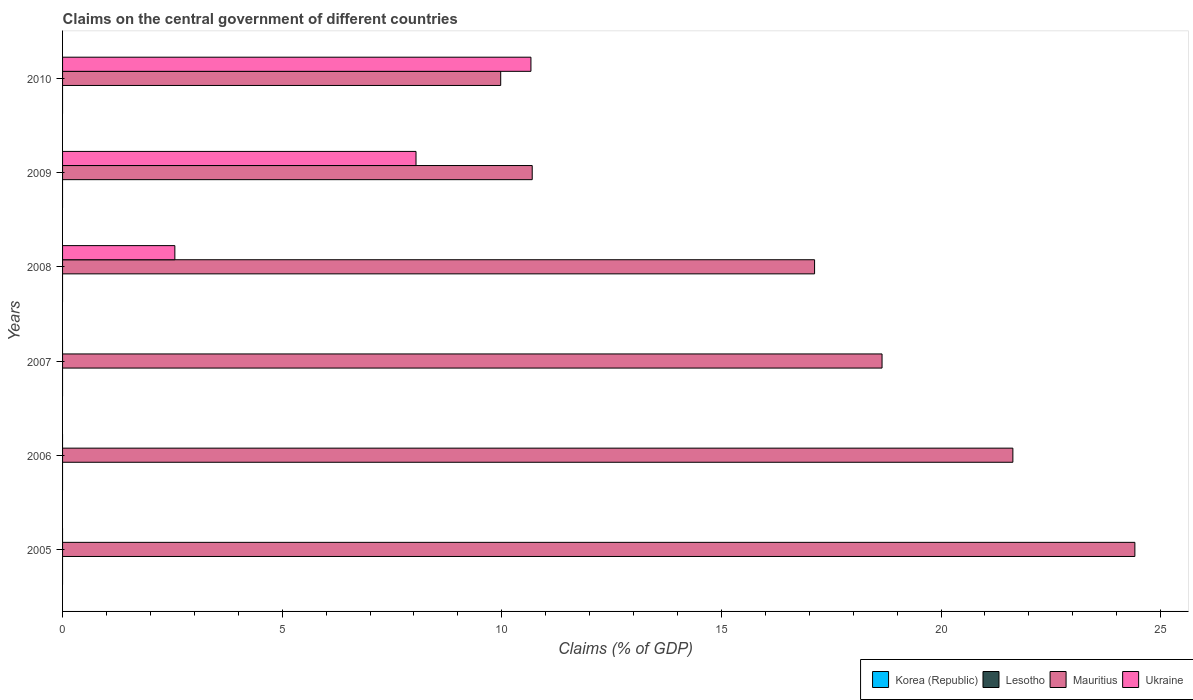Are the number of bars per tick equal to the number of legend labels?
Offer a very short reply. No. How many bars are there on the 3rd tick from the top?
Offer a terse response. 2. What is the label of the 3rd group of bars from the top?
Your answer should be very brief. 2008. In how many cases, is the number of bars for a given year not equal to the number of legend labels?
Keep it short and to the point. 6. What is the percentage of GDP claimed on the central government in Mauritius in 2010?
Make the answer very short. 9.98. Across all years, what is the maximum percentage of GDP claimed on the central government in Mauritius?
Keep it short and to the point. 24.41. Across all years, what is the minimum percentage of GDP claimed on the central government in Lesotho?
Your response must be concise. 0. What is the difference between the percentage of GDP claimed on the central government in Mauritius in 2005 and that in 2009?
Provide a succinct answer. 13.72. What is the difference between the percentage of GDP claimed on the central government in Korea (Republic) in 2006 and the percentage of GDP claimed on the central government in Ukraine in 2008?
Offer a very short reply. -2.56. In how many years, is the percentage of GDP claimed on the central government in Mauritius greater than 15 %?
Provide a short and direct response. 4. What is the ratio of the percentage of GDP claimed on the central government in Mauritius in 2007 to that in 2008?
Provide a succinct answer. 1.09. Is the percentage of GDP claimed on the central government in Mauritius in 2005 less than that in 2008?
Your response must be concise. No. What is the difference between the highest and the second highest percentage of GDP claimed on the central government in Mauritius?
Ensure brevity in your answer.  2.78. What is the difference between the highest and the lowest percentage of GDP claimed on the central government in Ukraine?
Offer a terse response. 10.66. In how many years, is the percentage of GDP claimed on the central government in Korea (Republic) greater than the average percentage of GDP claimed on the central government in Korea (Republic) taken over all years?
Your answer should be compact. 0. Is the sum of the percentage of GDP claimed on the central government in Mauritius in 2007 and 2010 greater than the maximum percentage of GDP claimed on the central government in Korea (Republic) across all years?
Provide a succinct answer. Yes. Is it the case that in every year, the sum of the percentage of GDP claimed on the central government in Mauritius and percentage of GDP claimed on the central government in Ukraine is greater than the sum of percentage of GDP claimed on the central government in Lesotho and percentage of GDP claimed on the central government in Korea (Republic)?
Offer a terse response. Yes. Is it the case that in every year, the sum of the percentage of GDP claimed on the central government in Ukraine and percentage of GDP claimed on the central government in Lesotho is greater than the percentage of GDP claimed on the central government in Mauritius?
Your answer should be very brief. No. How many bars are there?
Provide a short and direct response. 9. How many years are there in the graph?
Make the answer very short. 6. What is the difference between two consecutive major ticks on the X-axis?
Your answer should be compact. 5. Are the values on the major ticks of X-axis written in scientific E-notation?
Your answer should be compact. No. Does the graph contain any zero values?
Your answer should be compact. Yes. Does the graph contain grids?
Offer a very short reply. No. Where does the legend appear in the graph?
Make the answer very short. Bottom right. How are the legend labels stacked?
Offer a terse response. Horizontal. What is the title of the graph?
Give a very brief answer. Claims on the central government of different countries. Does "Poland" appear as one of the legend labels in the graph?
Give a very brief answer. No. What is the label or title of the X-axis?
Keep it short and to the point. Claims (% of GDP). What is the Claims (% of GDP) in Lesotho in 2005?
Offer a very short reply. 0. What is the Claims (% of GDP) of Mauritius in 2005?
Make the answer very short. 24.41. What is the Claims (% of GDP) of Ukraine in 2005?
Offer a terse response. 0. What is the Claims (% of GDP) of Mauritius in 2006?
Your answer should be very brief. 21.64. What is the Claims (% of GDP) in Ukraine in 2006?
Offer a very short reply. 0. What is the Claims (% of GDP) of Korea (Republic) in 2007?
Keep it short and to the point. 0. What is the Claims (% of GDP) in Mauritius in 2007?
Your response must be concise. 18.66. What is the Claims (% of GDP) in Ukraine in 2007?
Your response must be concise. 0. What is the Claims (% of GDP) of Korea (Republic) in 2008?
Your answer should be very brief. 0. What is the Claims (% of GDP) in Lesotho in 2008?
Your answer should be compact. 0. What is the Claims (% of GDP) of Mauritius in 2008?
Keep it short and to the point. 17.12. What is the Claims (% of GDP) in Ukraine in 2008?
Provide a succinct answer. 2.56. What is the Claims (% of GDP) in Lesotho in 2009?
Provide a succinct answer. 0. What is the Claims (% of GDP) of Mauritius in 2009?
Keep it short and to the point. 10.69. What is the Claims (% of GDP) in Ukraine in 2009?
Your answer should be very brief. 8.05. What is the Claims (% of GDP) in Mauritius in 2010?
Ensure brevity in your answer.  9.98. What is the Claims (% of GDP) in Ukraine in 2010?
Offer a terse response. 10.66. Across all years, what is the maximum Claims (% of GDP) in Mauritius?
Ensure brevity in your answer.  24.41. Across all years, what is the maximum Claims (% of GDP) in Ukraine?
Offer a very short reply. 10.66. Across all years, what is the minimum Claims (% of GDP) in Mauritius?
Your answer should be compact. 9.98. Across all years, what is the minimum Claims (% of GDP) in Ukraine?
Offer a very short reply. 0. What is the total Claims (% of GDP) of Korea (Republic) in the graph?
Provide a short and direct response. 0. What is the total Claims (% of GDP) in Mauritius in the graph?
Keep it short and to the point. 102.5. What is the total Claims (% of GDP) of Ukraine in the graph?
Your answer should be very brief. 21.27. What is the difference between the Claims (% of GDP) of Mauritius in 2005 and that in 2006?
Your answer should be compact. 2.78. What is the difference between the Claims (% of GDP) of Mauritius in 2005 and that in 2007?
Make the answer very short. 5.76. What is the difference between the Claims (% of GDP) of Mauritius in 2005 and that in 2008?
Your response must be concise. 7.29. What is the difference between the Claims (% of GDP) of Mauritius in 2005 and that in 2009?
Your answer should be very brief. 13.72. What is the difference between the Claims (% of GDP) of Mauritius in 2005 and that in 2010?
Your answer should be very brief. 14.44. What is the difference between the Claims (% of GDP) in Mauritius in 2006 and that in 2007?
Offer a terse response. 2.98. What is the difference between the Claims (% of GDP) in Mauritius in 2006 and that in 2008?
Keep it short and to the point. 4.51. What is the difference between the Claims (% of GDP) of Mauritius in 2006 and that in 2009?
Offer a terse response. 10.94. What is the difference between the Claims (% of GDP) of Mauritius in 2006 and that in 2010?
Offer a terse response. 11.66. What is the difference between the Claims (% of GDP) of Mauritius in 2007 and that in 2008?
Make the answer very short. 1.54. What is the difference between the Claims (% of GDP) in Mauritius in 2007 and that in 2009?
Provide a succinct answer. 7.96. What is the difference between the Claims (% of GDP) in Mauritius in 2007 and that in 2010?
Your response must be concise. 8.68. What is the difference between the Claims (% of GDP) of Mauritius in 2008 and that in 2009?
Give a very brief answer. 6.43. What is the difference between the Claims (% of GDP) in Ukraine in 2008 and that in 2009?
Provide a short and direct response. -5.49. What is the difference between the Claims (% of GDP) of Mauritius in 2008 and that in 2010?
Provide a succinct answer. 7.15. What is the difference between the Claims (% of GDP) of Ukraine in 2008 and that in 2010?
Offer a very short reply. -8.11. What is the difference between the Claims (% of GDP) in Mauritius in 2009 and that in 2010?
Provide a succinct answer. 0.72. What is the difference between the Claims (% of GDP) in Ukraine in 2009 and that in 2010?
Keep it short and to the point. -2.62. What is the difference between the Claims (% of GDP) in Mauritius in 2005 and the Claims (% of GDP) in Ukraine in 2008?
Ensure brevity in your answer.  21.86. What is the difference between the Claims (% of GDP) in Mauritius in 2005 and the Claims (% of GDP) in Ukraine in 2009?
Keep it short and to the point. 16.37. What is the difference between the Claims (% of GDP) in Mauritius in 2005 and the Claims (% of GDP) in Ukraine in 2010?
Keep it short and to the point. 13.75. What is the difference between the Claims (% of GDP) in Mauritius in 2006 and the Claims (% of GDP) in Ukraine in 2008?
Your response must be concise. 19.08. What is the difference between the Claims (% of GDP) of Mauritius in 2006 and the Claims (% of GDP) of Ukraine in 2009?
Offer a terse response. 13.59. What is the difference between the Claims (% of GDP) of Mauritius in 2006 and the Claims (% of GDP) of Ukraine in 2010?
Offer a very short reply. 10.97. What is the difference between the Claims (% of GDP) in Mauritius in 2007 and the Claims (% of GDP) in Ukraine in 2008?
Give a very brief answer. 16.1. What is the difference between the Claims (% of GDP) of Mauritius in 2007 and the Claims (% of GDP) of Ukraine in 2009?
Offer a terse response. 10.61. What is the difference between the Claims (% of GDP) in Mauritius in 2007 and the Claims (% of GDP) in Ukraine in 2010?
Give a very brief answer. 7.99. What is the difference between the Claims (% of GDP) in Mauritius in 2008 and the Claims (% of GDP) in Ukraine in 2009?
Offer a very short reply. 9.07. What is the difference between the Claims (% of GDP) in Mauritius in 2008 and the Claims (% of GDP) in Ukraine in 2010?
Your answer should be very brief. 6.46. What is the difference between the Claims (% of GDP) in Mauritius in 2009 and the Claims (% of GDP) in Ukraine in 2010?
Provide a succinct answer. 0.03. What is the average Claims (% of GDP) in Korea (Republic) per year?
Make the answer very short. 0. What is the average Claims (% of GDP) of Lesotho per year?
Offer a very short reply. 0. What is the average Claims (% of GDP) of Mauritius per year?
Keep it short and to the point. 17.08. What is the average Claims (% of GDP) of Ukraine per year?
Make the answer very short. 3.54. In the year 2008, what is the difference between the Claims (% of GDP) in Mauritius and Claims (% of GDP) in Ukraine?
Provide a short and direct response. 14.56. In the year 2009, what is the difference between the Claims (% of GDP) in Mauritius and Claims (% of GDP) in Ukraine?
Make the answer very short. 2.65. In the year 2010, what is the difference between the Claims (% of GDP) of Mauritius and Claims (% of GDP) of Ukraine?
Provide a short and direct response. -0.69. What is the ratio of the Claims (% of GDP) of Mauritius in 2005 to that in 2006?
Your response must be concise. 1.13. What is the ratio of the Claims (% of GDP) of Mauritius in 2005 to that in 2007?
Keep it short and to the point. 1.31. What is the ratio of the Claims (% of GDP) in Mauritius in 2005 to that in 2008?
Keep it short and to the point. 1.43. What is the ratio of the Claims (% of GDP) in Mauritius in 2005 to that in 2009?
Provide a short and direct response. 2.28. What is the ratio of the Claims (% of GDP) in Mauritius in 2005 to that in 2010?
Provide a succinct answer. 2.45. What is the ratio of the Claims (% of GDP) in Mauritius in 2006 to that in 2007?
Your answer should be compact. 1.16. What is the ratio of the Claims (% of GDP) in Mauritius in 2006 to that in 2008?
Keep it short and to the point. 1.26. What is the ratio of the Claims (% of GDP) of Mauritius in 2006 to that in 2009?
Ensure brevity in your answer.  2.02. What is the ratio of the Claims (% of GDP) of Mauritius in 2006 to that in 2010?
Your answer should be compact. 2.17. What is the ratio of the Claims (% of GDP) of Mauritius in 2007 to that in 2008?
Ensure brevity in your answer.  1.09. What is the ratio of the Claims (% of GDP) of Mauritius in 2007 to that in 2009?
Keep it short and to the point. 1.74. What is the ratio of the Claims (% of GDP) of Mauritius in 2007 to that in 2010?
Keep it short and to the point. 1.87. What is the ratio of the Claims (% of GDP) of Mauritius in 2008 to that in 2009?
Provide a succinct answer. 1.6. What is the ratio of the Claims (% of GDP) of Ukraine in 2008 to that in 2009?
Your response must be concise. 0.32. What is the ratio of the Claims (% of GDP) in Mauritius in 2008 to that in 2010?
Your answer should be very brief. 1.72. What is the ratio of the Claims (% of GDP) in Ukraine in 2008 to that in 2010?
Your answer should be compact. 0.24. What is the ratio of the Claims (% of GDP) in Mauritius in 2009 to that in 2010?
Offer a very short reply. 1.07. What is the ratio of the Claims (% of GDP) in Ukraine in 2009 to that in 2010?
Ensure brevity in your answer.  0.75. What is the difference between the highest and the second highest Claims (% of GDP) in Mauritius?
Keep it short and to the point. 2.78. What is the difference between the highest and the second highest Claims (% of GDP) of Ukraine?
Your response must be concise. 2.62. What is the difference between the highest and the lowest Claims (% of GDP) of Mauritius?
Make the answer very short. 14.44. What is the difference between the highest and the lowest Claims (% of GDP) of Ukraine?
Your response must be concise. 10.66. 